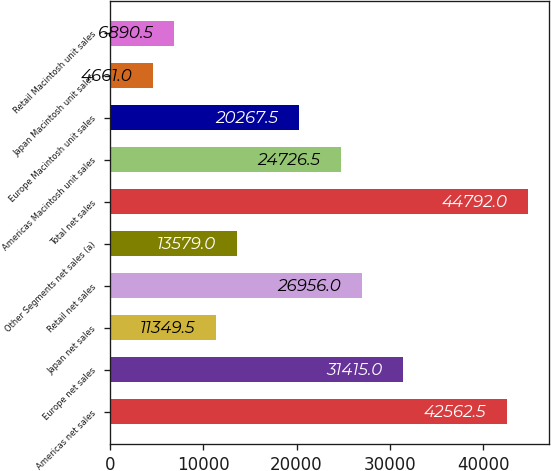Convert chart to OTSL. <chart><loc_0><loc_0><loc_500><loc_500><bar_chart><fcel>Americas net sales<fcel>Europe net sales<fcel>Japan net sales<fcel>Retail net sales<fcel>Other Segments net sales (a)<fcel>Total net sales<fcel>Americas Macintosh unit sales<fcel>Europe Macintosh unit sales<fcel>Japan Macintosh unit sales<fcel>Retail Macintosh unit sales<nl><fcel>42562.5<fcel>31415<fcel>11349.5<fcel>26956<fcel>13579<fcel>44792<fcel>24726.5<fcel>20267.5<fcel>4661<fcel>6890.5<nl></chart> 